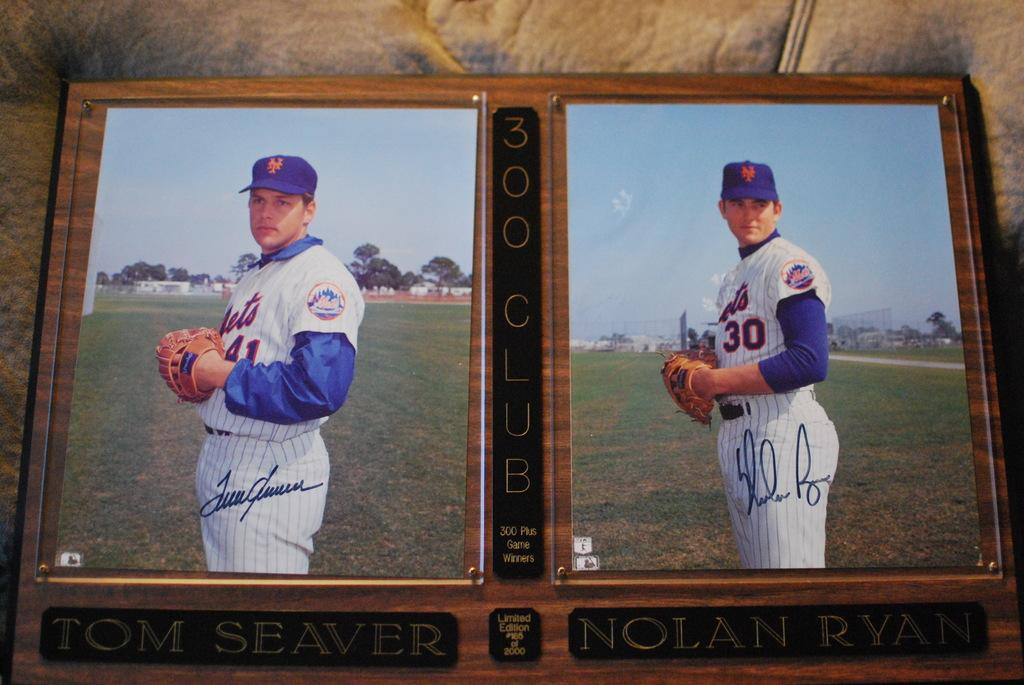<image>
Describe the image concisely. A close up of two photos of baseball players Tom Seaver and Nolan Ryan who are both in the 300 club 